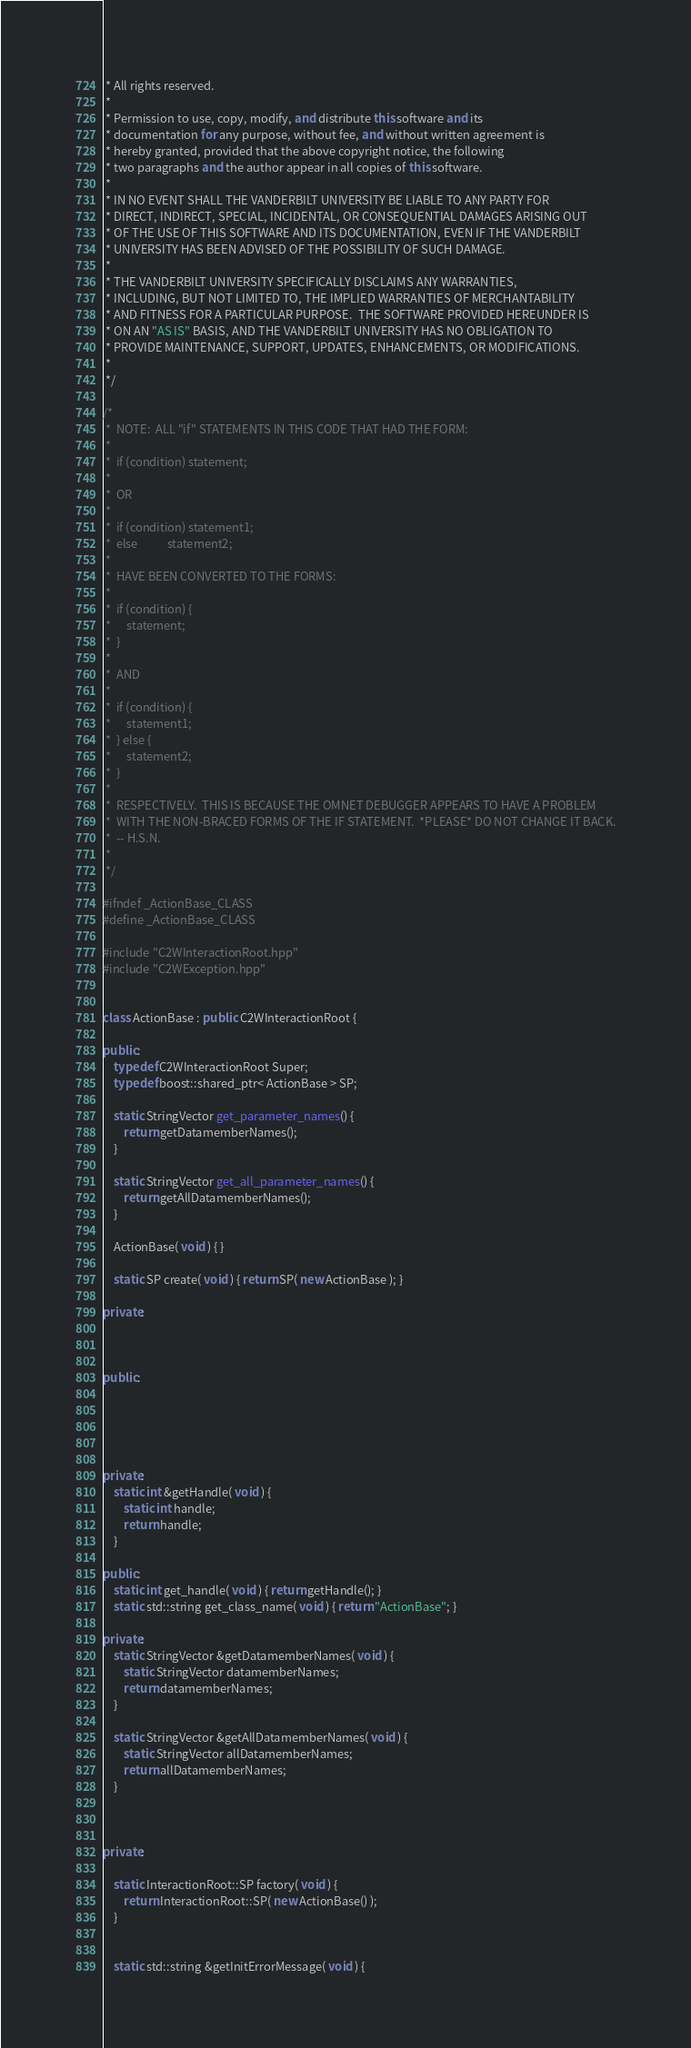<code> <loc_0><loc_0><loc_500><loc_500><_C++_> * All rights reserved.
 *
 * Permission to use, copy, modify, and distribute this software and its
 * documentation for any purpose, without fee, and without written agreement is
 * hereby granted, provided that the above copyright notice, the following
 * two paragraphs and the author appear in all copies of this software.
 *
 * IN NO EVENT SHALL THE VANDERBILT UNIVERSITY BE LIABLE TO ANY PARTY FOR
 * DIRECT, INDIRECT, SPECIAL, INCIDENTAL, OR CONSEQUENTIAL DAMAGES ARISING OUT
 * OF THE USE OF THIS SOFTWARE AND ITS DOCUMENTATION, EVEN IF THE VANDERBILT
 * UNIVERSITY HAS BEEN ADVISED OF THE POSSIBILITY OF SUCH DAMAGE.
 *
 * THE VANDERBILT UNIVERSITY SPECIFICALLY DISCLAIMS ANY WARRANTIES,
 * INCLUDING, BUT NOT LIMITED TO, THE IMPLIED WARRANTIES OF MERCHANTABILITY
 * AND FITNESS FOR A PARTICULAR PURPOSE.  THE SOFTWARE PROVIDED HEREUNDER IS
 * ON AN "AS IS" BASIS, AND THE VANDERBILT UNIVERSITY HAS NO OBLIGATION TO
 * PROVIDE MAINTENANCE, SUPPORT, UPDATES, ENHANCEMENTS, OR MODIFICATIONS.
 *
 */

/*
 * 	NOTE:  ALL "if" STATEMENTS IN THIS CODE THAT HAD THE FORM:
 *
 *  if (condition) statement;
 *
 *	OR
 *
 *  if (condition) statement1;
 *  else           statement2;
 *
 *  HAVE BEEN CONVERTED TO THE FORMS:
 *
 *  if (condition) {
 *		statement;
 *	}
 *
 *	AND
 *
 *  if (condition) {
 *		statement1;
 *	} else {
 *		statement2;
 *	}
 *
 *	RESPECTIVELY.  THIS IS BECAUSE THE OMNET DEBUGGER APPEARS TO HAVE A PROBLEM
 *  WITH THE NON-BRACED FORMS OF THE IF STATEMENT.  *PLEASE* DO NOT CHANGE IT BACK.
 *  -- H.S.N.
 *
 */

#ifndef _ActionBase_CLASS
#define _ActionBase_CLASS

#include "C2WInteractionRoot.hpp"
#include "C2WException.hpp"


class ActionBase : public C2WInteractionRoot {

public:
	typedef C2WInteractionRoot Super;
	typedef boost::shared_ptr< ActionBase > SP;

	static StringVector get_parameter_names() {
		return getDatamemberNames();
	}

	static StringVector get_all_parameter_names() {
		return getAllDatamemberNames();
	}

	ActionBase( void ) { }
	
	static SP create( void ) { return SP( new ActionBase ); }

private:
	
	
	
public:
	
	
	


private:
	static int &getHandle( void ) {
		static int handle;
		return handle;
	}

public:
	static int get_handle( void ) { return getHandle(); }
	static std::string get_class_name( void ) { return "ActionBase"; }

private:
	static StringVector &getDatamemberNames( void ) {
		static StringVector datamemberNames;
		return datamemberNames;
	}

	static StringVector &getAllDatamemberNames( void ) {
		static StringVector allDatamemberNames;
		return allDatamemberNames;
	}



private:

	static InteractionRoot::SP factory( void ) {
		return InteractionRoot::SP( new ActionBase() );
	}


	static std::string &getInitErrorMessage( void ) {</code> 